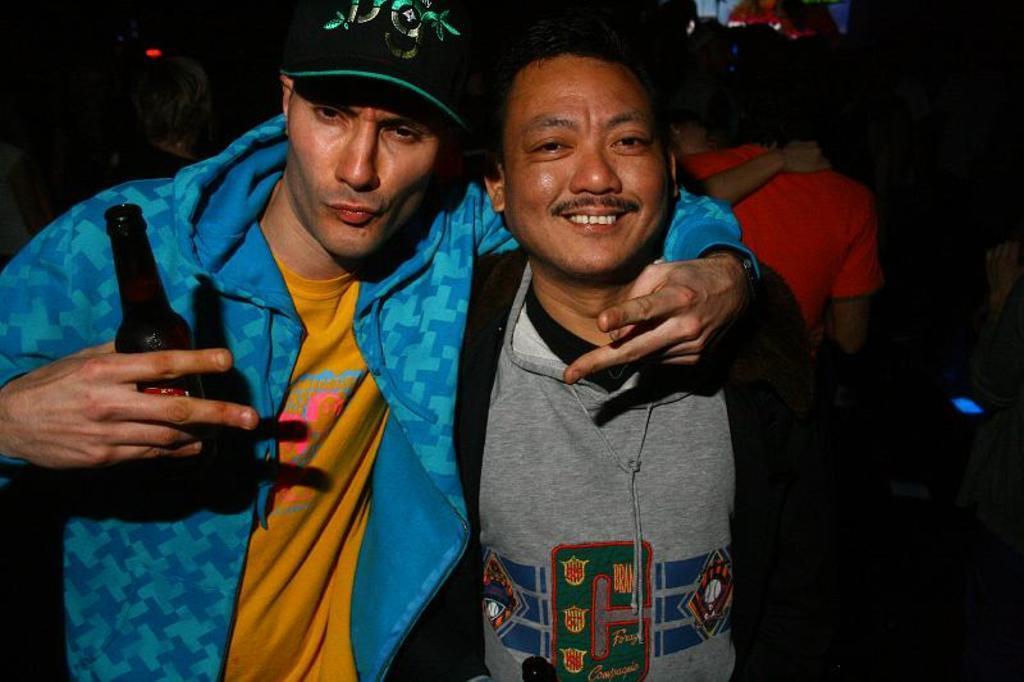Describe this image in one or two sentences. In this picture there is a man who is wearing a yellow t shirt and a blue jacket. He is holding a bottle in his hand. There is also another man who is wearing a grey shirt and a black jacket. At the background, there are group of people. There is a light at the background. 